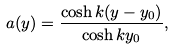<formula> <loc_0><loc_0><loc_500><loc_500>a ( y ) = \frac { \cosh k ( y - y _ { 0 } ) } { \cosh k y _ { 0 } } ,</formula> 